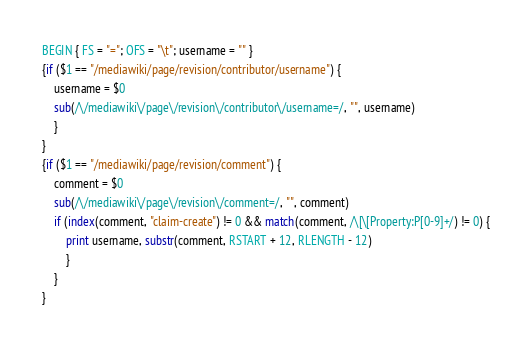Convert code to text. <code><loc_0><loc_0><loc_500><loc_500><_Awk_>BEGIN { FS = "="; OFS = "\t"; username = "" }
{if ($1 == "/mediawiki/page/revision/contributor/username") {
	username = $0
	sub(/\/mediawiki\/page\/revision\/contributor\/username=/, "", username)
	}
}
{if ($1 == "/mediawiki/page/revision/comment") {
	comment = $0
	sub(/\/mediawiki\/page\/revision\/comment=/, "", comment)
	if (index(comment, "claim-create") != 0 && match(comment, /\[\[Property:P[0-9]+/) != 0) {
		print username, substr(comment, RSTART + 12, RLENGTH - 12)
		}
	}
}
</code> 